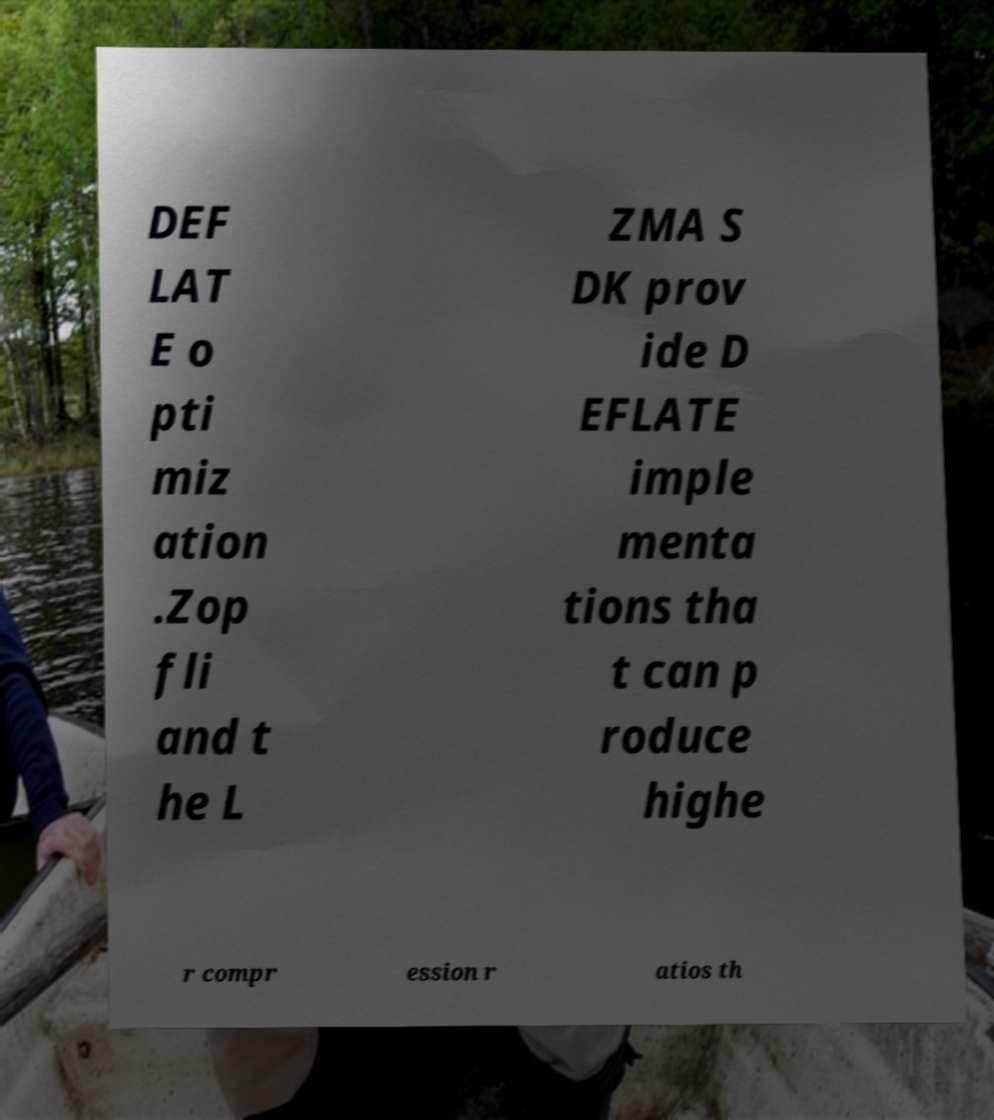Please read and relay the text visible in this image. What does it say? DEF LAT E o pti miz ation .Zop fli and t he L ZMA S DK prov ide D EFLATE imple menta tions tha t can p roduce highe r compr ession r atios th 